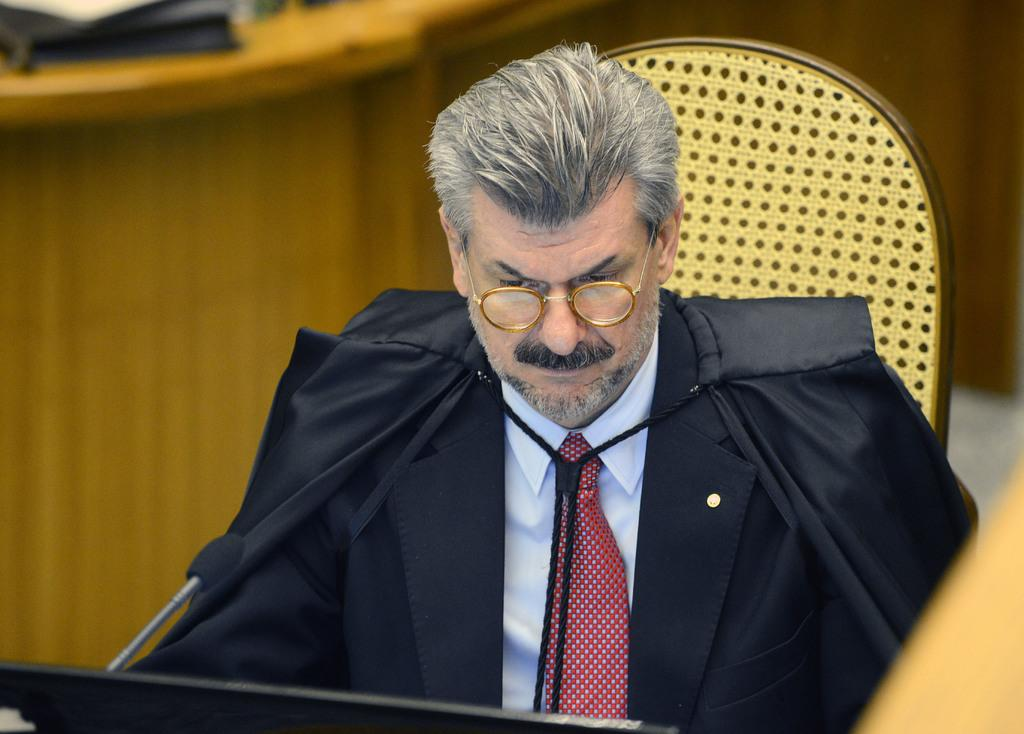Who or what is present in the image? There is a person in the image. What can be observed about the person's appearance? The person is wearing spectacles. What is the person doing in the image? The person is sitting on a chair. What object is visible in the image that is typically used for amplifying sound? There is a microphone in the image. What type of background is present in the image? There is a wooden background in the image. What language is the person speaking in the image? The image does not provide any information about the language being spoken. 